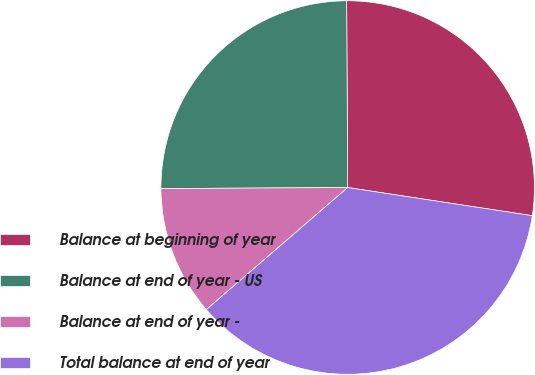Convert chart. <chart><loc_0><loc_0><loc_500><loc_500><pie_chart><fcel>Balance at beginning of year<fcel>Balance at end of year - US<fcel>Balance at end of year -<fcel>Total balance at end of year<nl><fcel>27.5%<fcel>25.0%<fcel>11.25%<fcel>36.25%<nl></chart> 